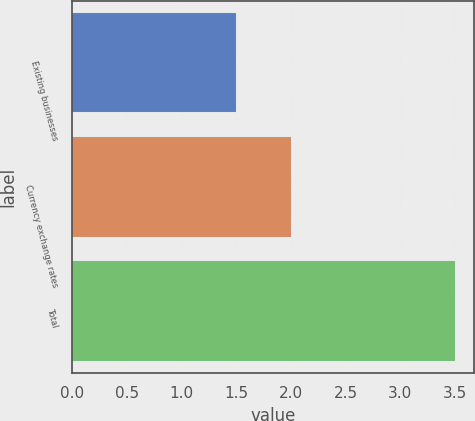Convert chart to OTSL. <chart><loc_0><loc_0><loc_500><loc_500><bar_chart><fcel>Existing businesses<fcel>Currency exchange rates<fcel>Total<nl><fcel>1.5<fcel>2<fcel>3.5<nl></chart> 